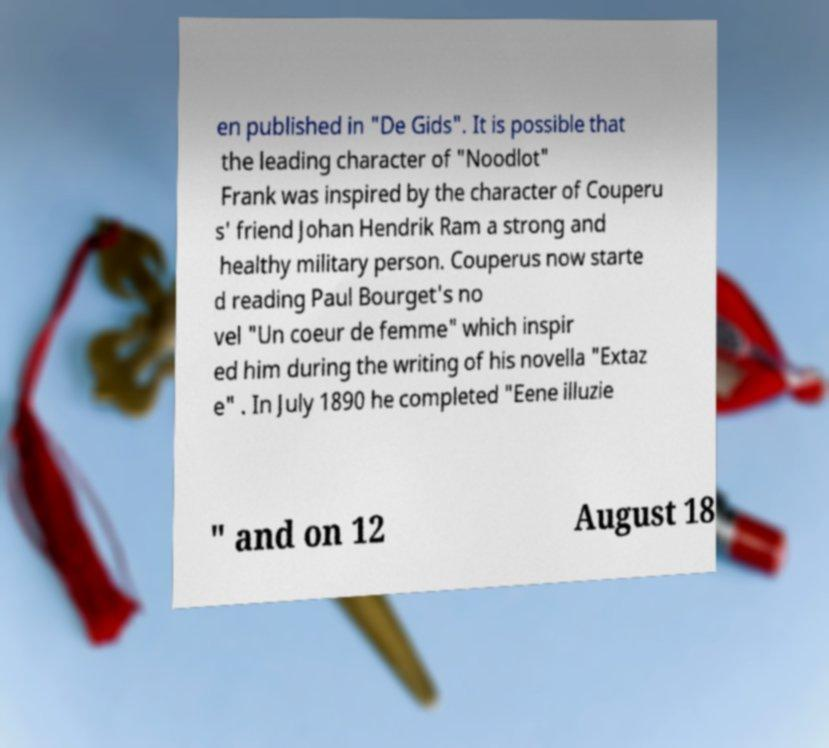Please read and relay the text visible in this image. What does it say? en published in "De Gids". It is possible that the leading character of "Noodlot" Frank was inspired by the character of Couperu s' friend Johan Hendrik Ram a strong and healthy military person. Couperus now starte d reading Paul Bourget's no vel "Un coeur de femme" which inspir ed him during the writing of his novella "Extaz e" . In July 1890 he completed "Eene illuzie " and on 12 August 18 